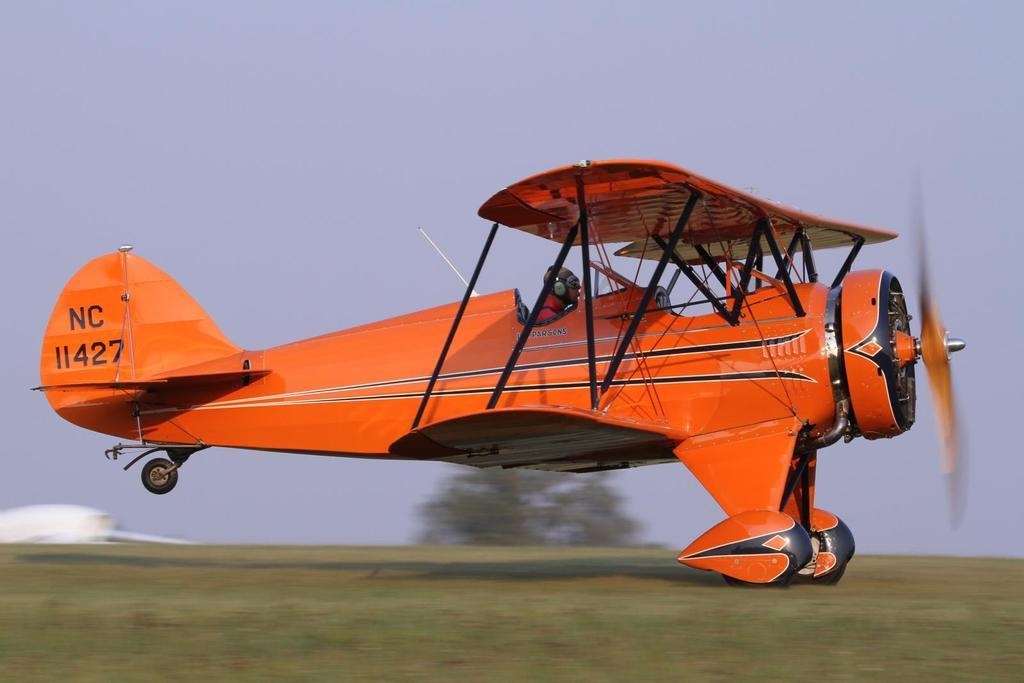<image>
Render a clear and concise summary of the photo. a small orange jet that says 'nc 11427' on the back side of it 